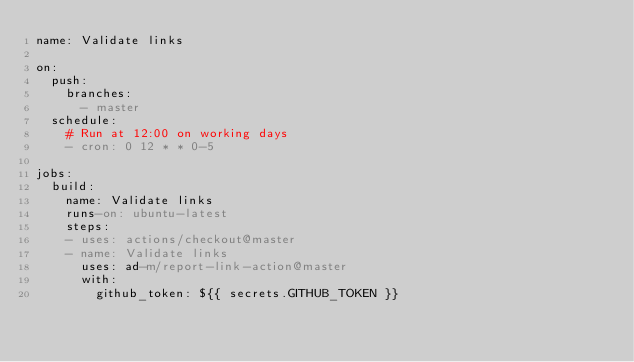<code> <loc_0><loc_0><loc_500><loc_500><_YAML_>name: Validate links

on:
  push:
    branches:
      - master
  schedule:
    # Run at 12:00 on working days
    - cron: 0 12 * * 0-5

jobs:
  build:
    name: Validate links
    runs-on: ubuntu-latest
    steps:
    - uses: actions/checkout@master
    - name: Validate links
      uses: ad-m/report-link-action@master
      with:
        github_token: ${{ secrets.GITHUB_TOKEN }}
</code> 